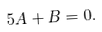Convert formula to latex. <formula><loc_0><loc_0><loc_500><loc_500>5 A + B = 0 .</formula> 